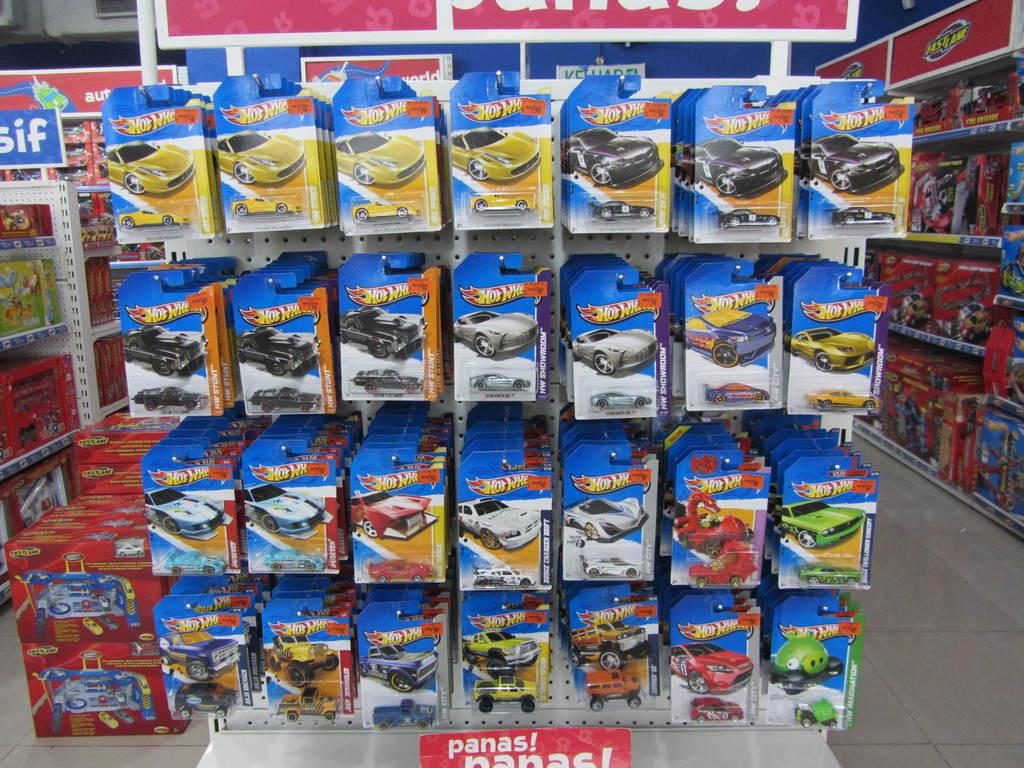<image>
Summarize the visual content of the image. lots of hot wheels toys cars on display at the toy store 